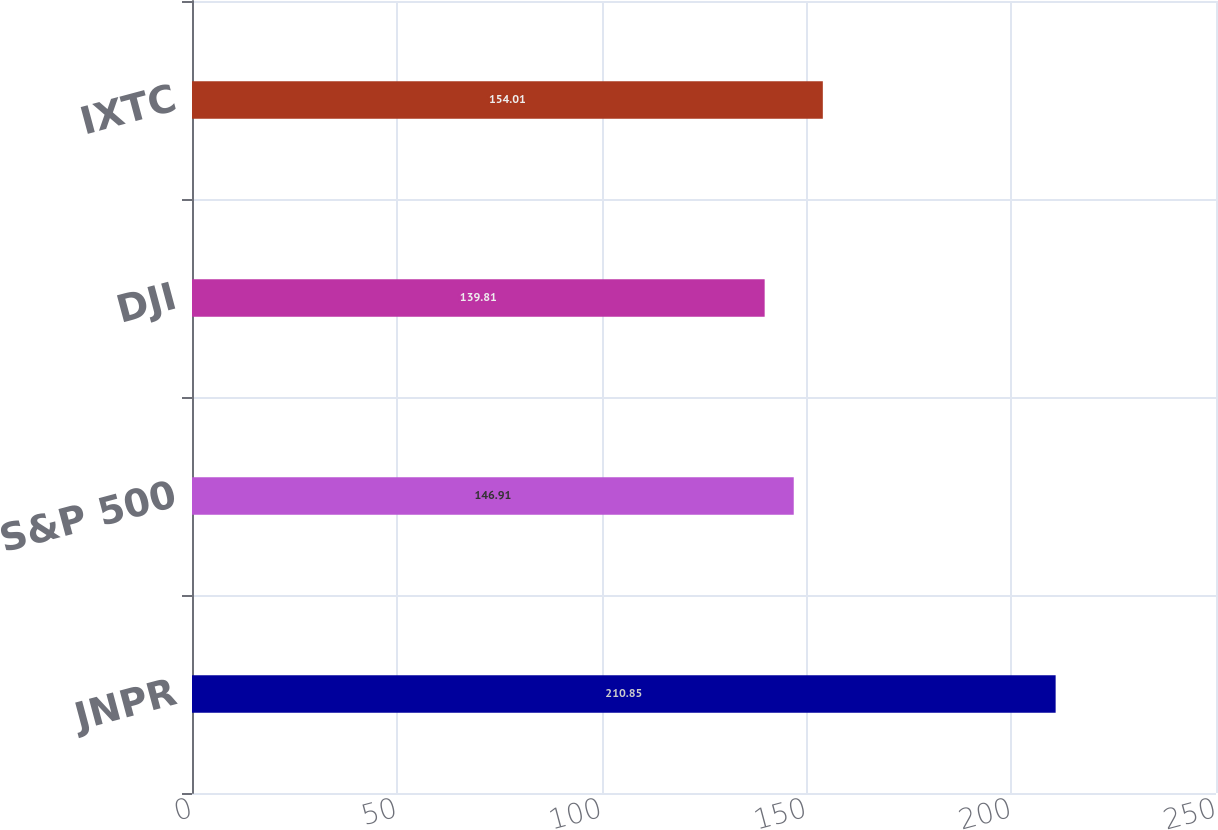<chart> <loc_0><loc_0><loc_500><loc_500><bar_chart><fcel>JNPR<fcel>S&P 500<fcel>DJI<fcel>IXTC<nl><fcel>210.85<fcel>146.91<fcel>139.81<fcel>154.01<nl></chart> 